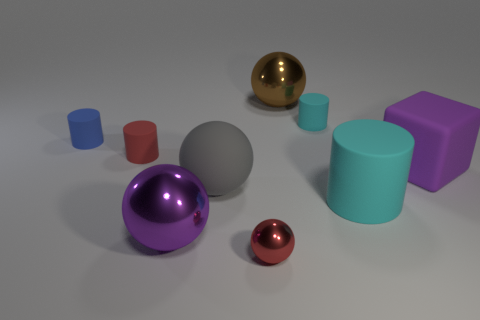Subtract 1 balls. How many balls are left? 3 Subtract all brown cylinders. Subtract all brown spheres. How many cylinders are left? 4 Subtract all blocks. How many objects are left? 8 Subtract all big purple things. Subtract all tiny rubber cylinders. How many objects are left? 4 Add 7 small red spheres. How many small red spheres are left? 8 Add 6 tiny blue objects. How many tiny blue objects exist? 7 Subtract 0 green cubes. How many objects are left? 9 